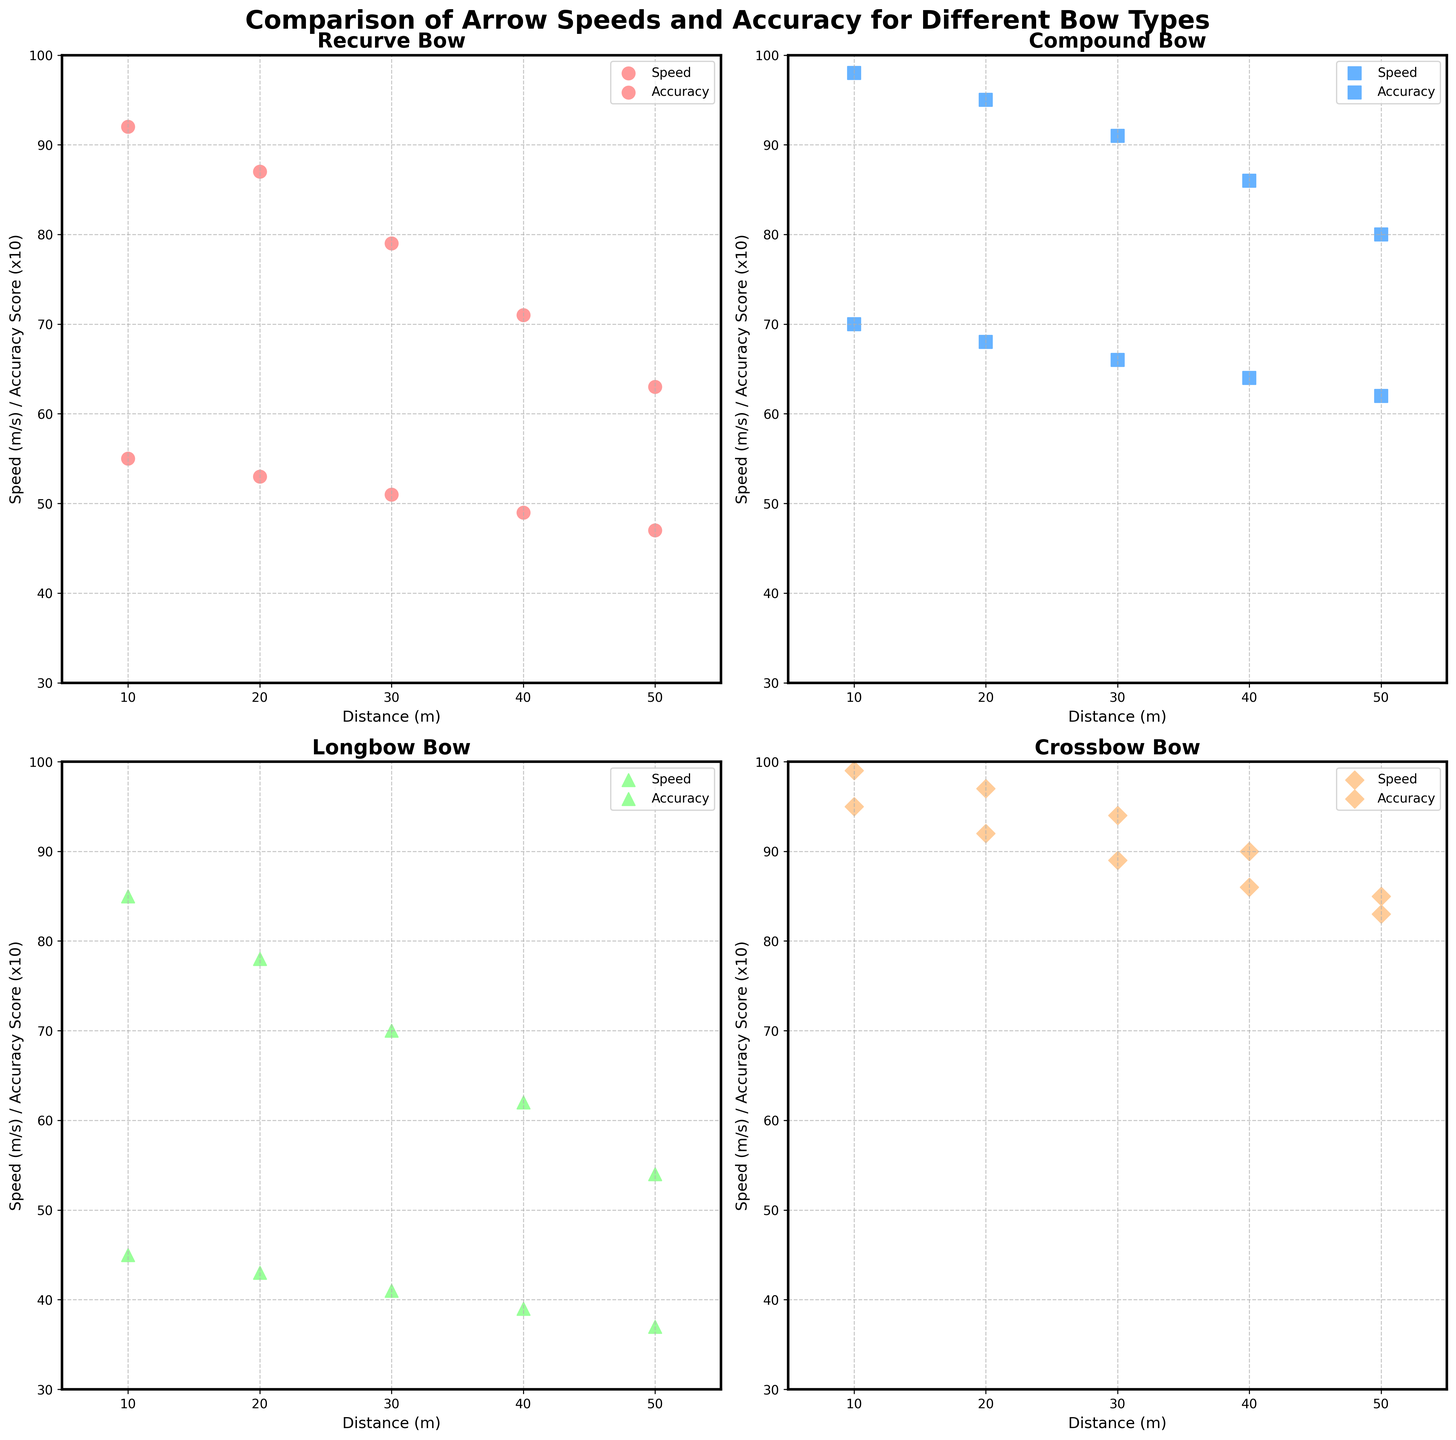What are the bow types displayed in the subplot? The subplot displays data for four bow types, which are mentioned in the legend and title of each subplot: Recurve, Compound, Longbow, and Crossbow.
Answer: Recurve, Compound, Longbow, Crossbow What is the title of each individual subplot? Each individual subplot has a title indicating the bow type it represents (e.g., "Recurve Bow", "Compound Bow", "Longbow", "Crossbow"). This information appears at the top of each subplot.
Answer: Recurve Bow, Compound Bow, Longbow, Crossbow For which bow type does Arrow Speed decrease the most from 10m to 50m? To determine this, look at the Arrow Speed data points for each bow type from 10m to 50m. The Recurve Bow decreases from 55 m/s to 47 m/s (8 m/s), Compound Bow from 70 m/s to 62 m/s (8 m/s), Longbow from 45 m/s to 37 m/s (8 m/s), and Crossbow from 95 m/s to 83 m/s (12 m/s). The Crossbow shows the largest decrease.
Answer: Crossbow Between the Compound Bow and Recurve Bow, which one maintains higher accuracy scores at 30m? Compare the accuracy scores at 30m for both bow types. The Compound Bow has an accuracy score of 9.1, while the Recurve Bow has an accuracy score of 7.9. Thus, the Compound Bow maintains higher accuracy.
Answer: Compound Bow What is the combined accuracy score of the Crossbow at 20m, 30m, and 40m? Add the accuracy scores of the Crossbow at 20m, 30m, and 40m. The scores are 9.7, 9.4, and 9.0 respectively. The sum is 9.7 + 9.4 + 9.0 = 28.1.
Answer: 28.1 Which bow type demonstrates the highest arrow speed overall? By comparing the highest values of arrow speed for each bow type, 95 m/s for Crossbow, 70 m/s for Compound, 55 m/s for Recurve, and 45 m/s for Longbow, the Crossbow demonstrates the highest speed overall.
Answer: Crossbow Does the accuracy score for the Recurve Bow consistently decrease as distance increases? Evaluate the accuracy scores for the Recurve Bow at increasing distances (9.2, 8.7, 7.9, 7.1, 6.3). The scores consistently decrease.
Answer: Yes How does the accuracy score of the Longbow at 50m compare to that of the Compound Bow at 50m? Compare the accuracy scores: Longbow has 5.4 and Compound Bow has 8.0 at 50m. The Longbow's accuracy score is lower.
Answer: Longbow's accuracy is lower What is the average Arrow Speed of the Compound Bow across all distances? The Arrow Speed for the Compound Bow across distances (70, 68, 66, 64, 62). Sum these speeds (70+68+66+64+62 = 330) and divide by 5 (330/5 = 66). The average speed is 66 m/s.
Answer: 66 m/s 